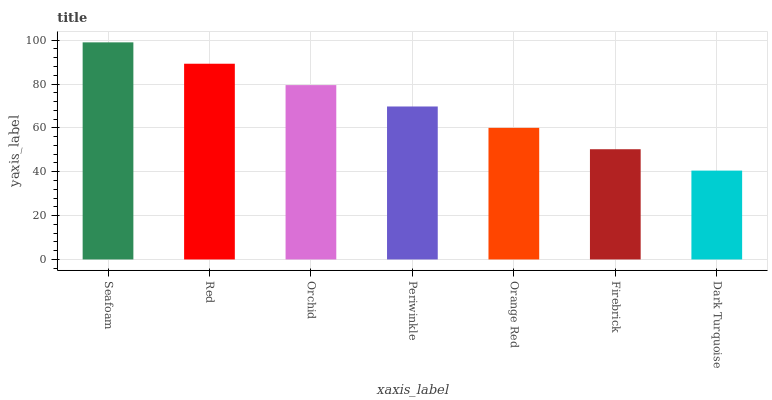Is Dark Turquoise the minimum?
Answer yes or no. Yes. Is Seafoam the maximum?
Answer yes or no. Yes. Is Red the minimum?
Answer yes or no. No. Is Red the maximum?
Answer yes or no. No. Is Seafoam greater than Red?
Answer yes or no. Yes. Is Red less than Seafoam?
Answer yes or no. Yes. Is Red greater than Seafoam?
Answer yes or no. No. Is Seafoam less than Red?
Answer yes or no. No. Is Periwinkle the high median?
Answer yes or no. Yes. Is Periwinkle the low median?
Answer yes or no. Yes. Is Firebrick the high median?
Answer yes or no. No. Is Orange Red the low median?
Answer yes or no. No. 